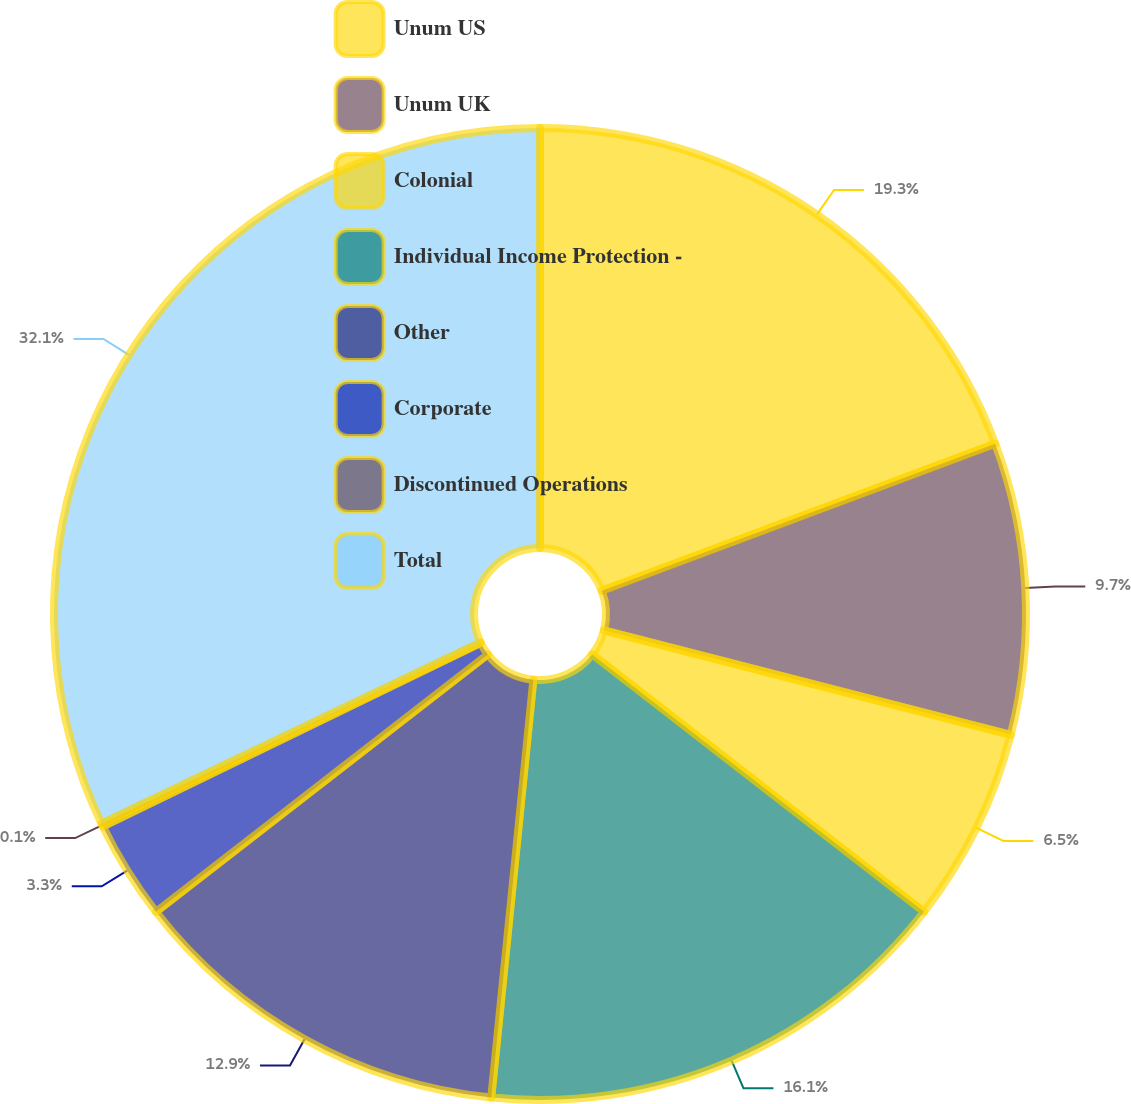Convert chart to OTSL. <chart><loc_0><loc_0><loc_500><loc_500><pie_chart><fcel>Unum US<fcel>Unum UK<fcel>Colonial<fcel>Individual Income Protection -<fcel>Other<fcel>Corporate<fcel>Discontinued Operations<fcel>Total<nl><fcel>19.3%<fcel>9.7%<fcel>6.5%<fcel>16.1%<fcel>12.9%<fcel>3.3%<fcel>0.1%<fcel>32.1%<nl></chart> 